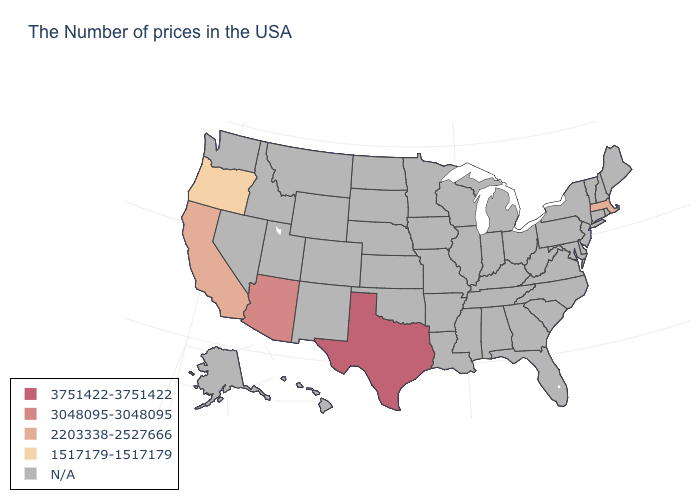Is the legend a continuous bar?
Short answer required. No. What is the highest value in the USA?
Write a very short answer. 3751422-3751422. Is the legend a continuous bar?
Quick response, please. No. How many symbols are there in the legend?
Give a very brief answer. 5. Name the states that have a value in the range 1517179-1517179?
Give a very brief answer. Oregon. Does Oregon have the lowest value in the USA?
Keep it brief. Yes. Name the states that have a value in the range 1517179-1517179?
Write a very short answer. Oregon. What is the value of Maine?
Keep it brief. N/A. What is the value of Indiana?
Give a very brief answer. N/A. What is the highest value in states that border Colorado?
Quick response, please. 3048095-3048095. Name the states that have a value in the range 1517179-1517179?
Keep it brief. Oregon. Does the map have missing data?
Concise answer only. Yes. Name the states that have a value in the range 2203338-2527666?
Concise answer only. Massachusetts, California. 